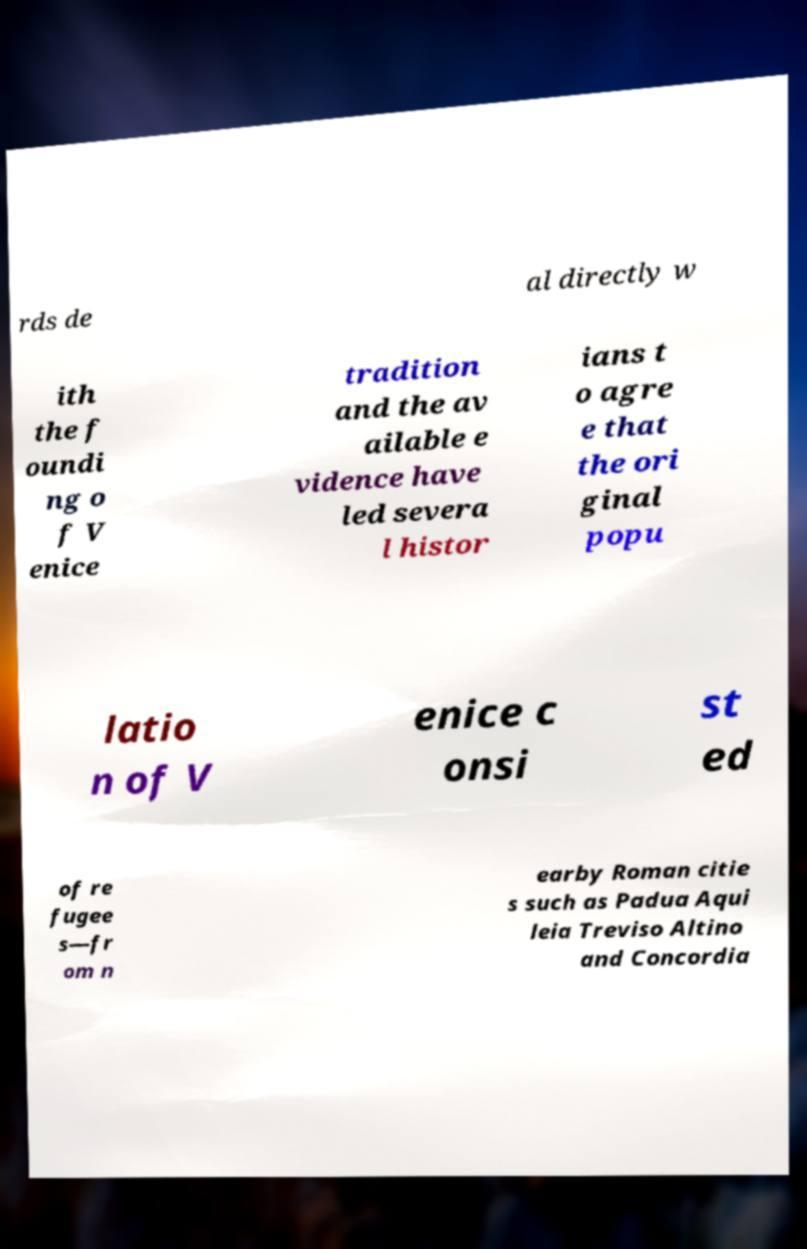Could you assist in decoding the text presented in this image and type it out clearly? rds de al directly w ith the f oundi ng o f V enice tradition and the av ailable e vidence have led severa l histor ians t o agre e that the ori ginal popu latio n of V enice c onsi st ed of re fugee s—fr om n earby Roman citie s such as Padua Aqui leia Treviso Altino and Concordia 